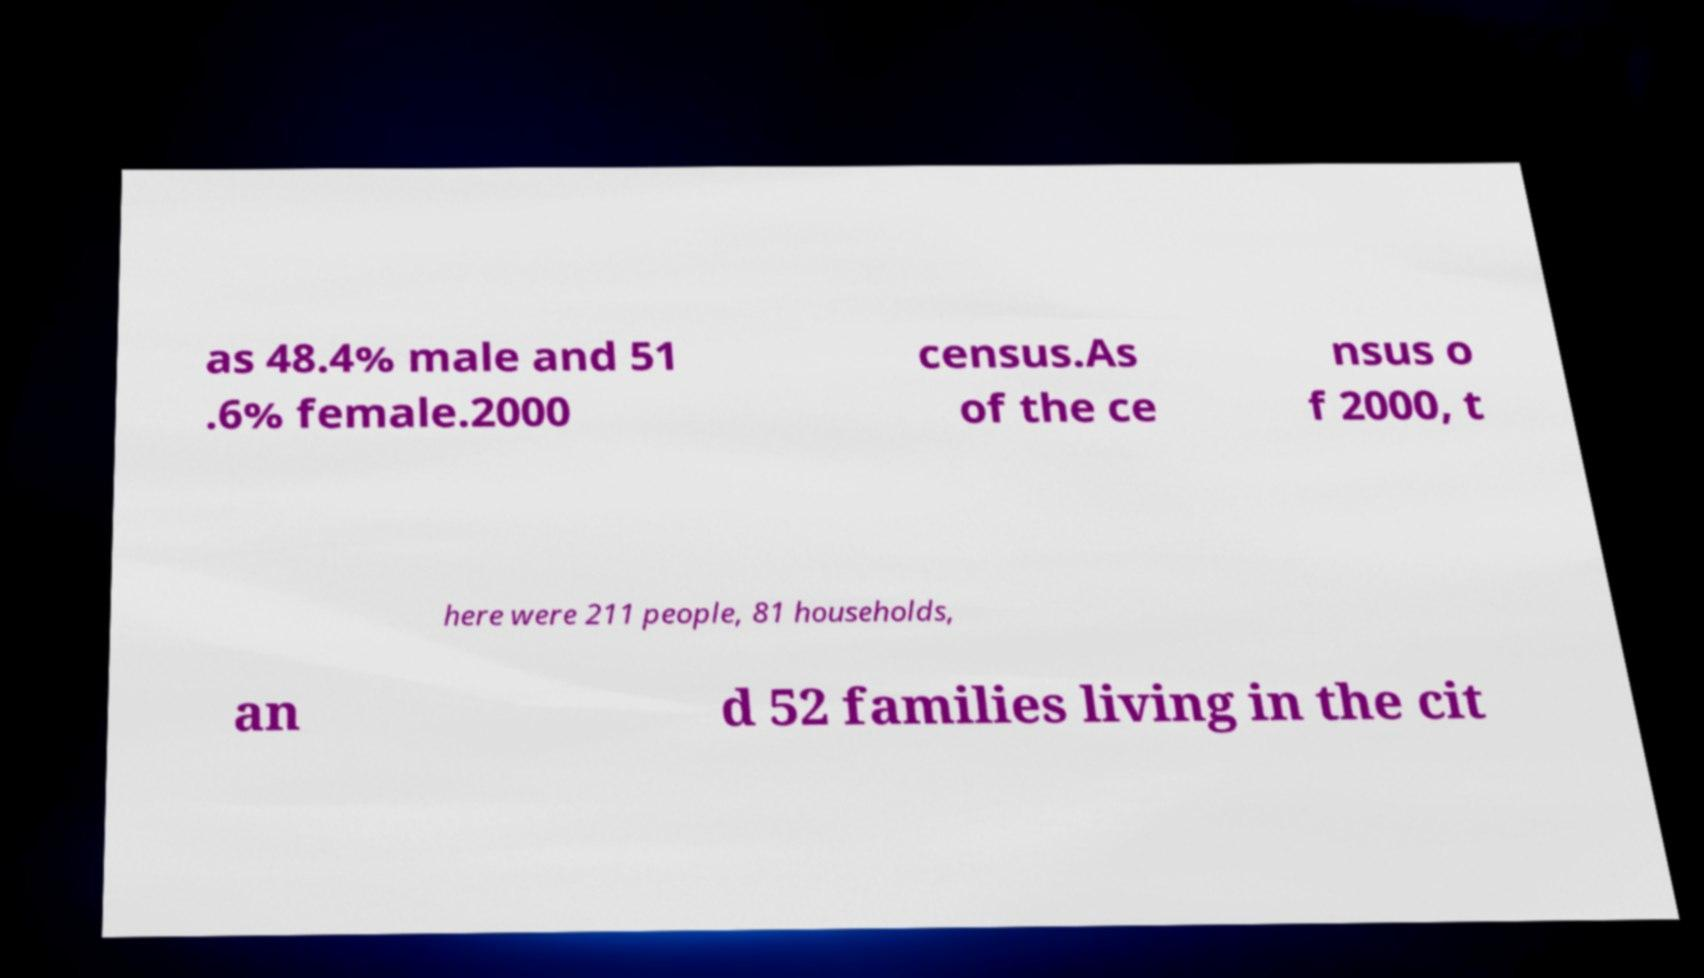There's text embedded in this image that I need extracted. Can you transcribe it verbatim? as 48.4% male and 51 .6% female.2000 census.As of the ce nsus o f 2000, t here were 211 people, 81 households, an d 52 families living in the cit 